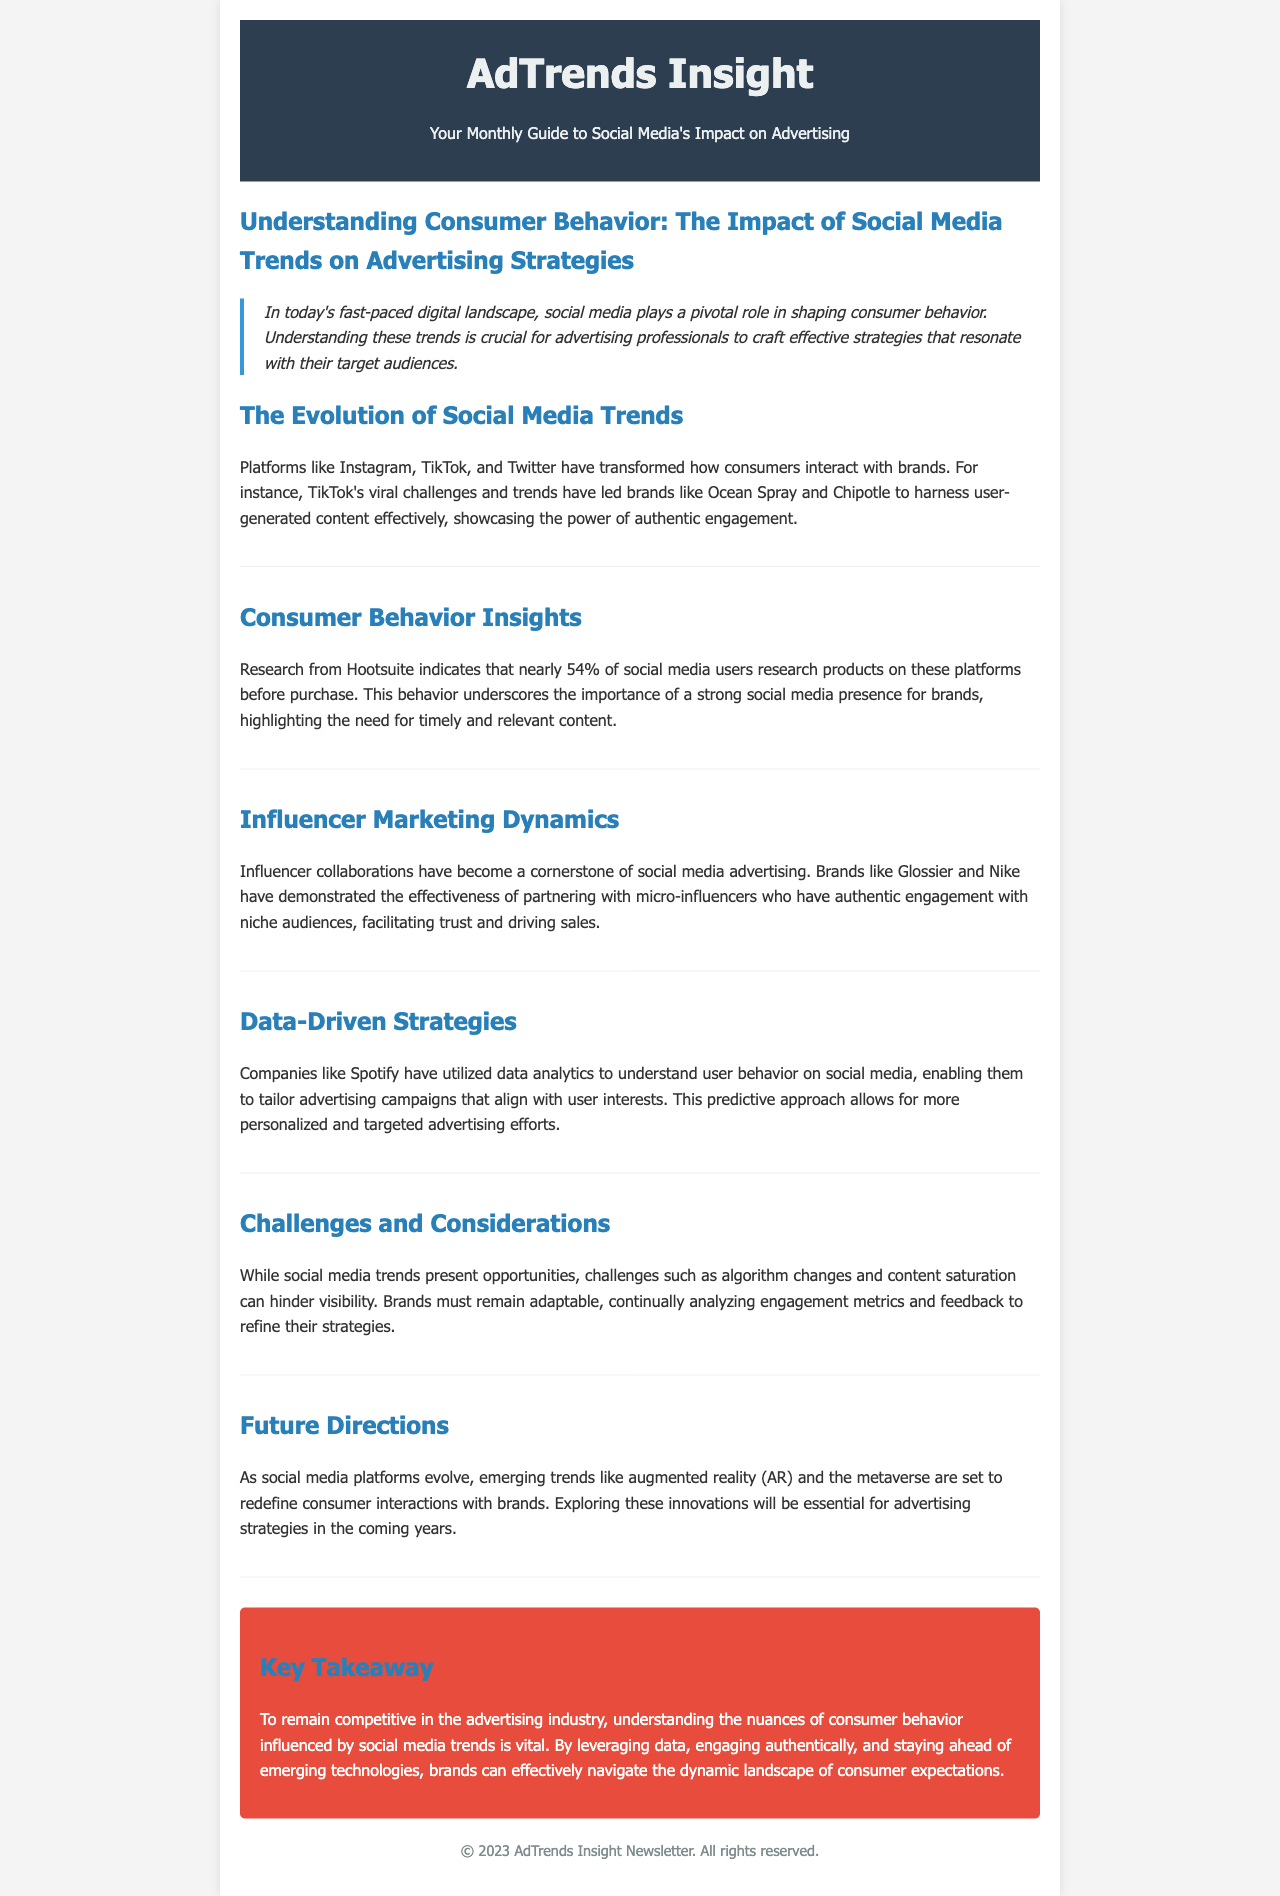What is the title of the newsletter? The title of the newsletter is given in the header section.
Answer: AdTrends Insight What percentage of social media users research products on these platforms before purchase? This information is stated in the Consumer Behavior Insights section.
Answer: 54% Which brands effectively implemented user-generated content through TikTok? The document mentions specific brands in the Evolution of Social Media Trends section.
Answer: Ocean Spray and Chipotle What marketing strategy has become a cornerstone of social media advertising? This is mentioned in the Influencer Marketing Dynamics section.
Answer: Influencer collaborations Which company utilized data analytics to tailor advertising campaigns? The document specifies a company in the Data-Driven Strategies section.
Answer: Spotify What challenges must brands consider when using social media trends? The Challenges and Considerations section discusses this topic.
Answer: Algorithm changes and content saturation What technologies are mentioned as future directions for advertising? Future technological directions are outlined in the Future Directions section.
Answer: Augmented reality and metaverse What is the key takeaway from the document? The conclusion section summarizes the important point.
Answer: Understanding consumer behavior influenced by social media trends is vital 